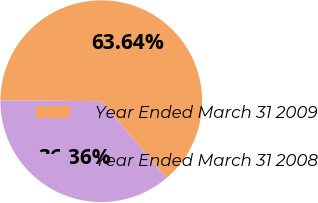Convert chart to OTSL. <chart><loc_0><loc_0><loc_500><loc_500><pie_chart><fcel>Year Ended March 31 2009<fcel>Year Ended March 31 2008<nl><fcel>63.64%<fcel>36.36%<nl></chart> 